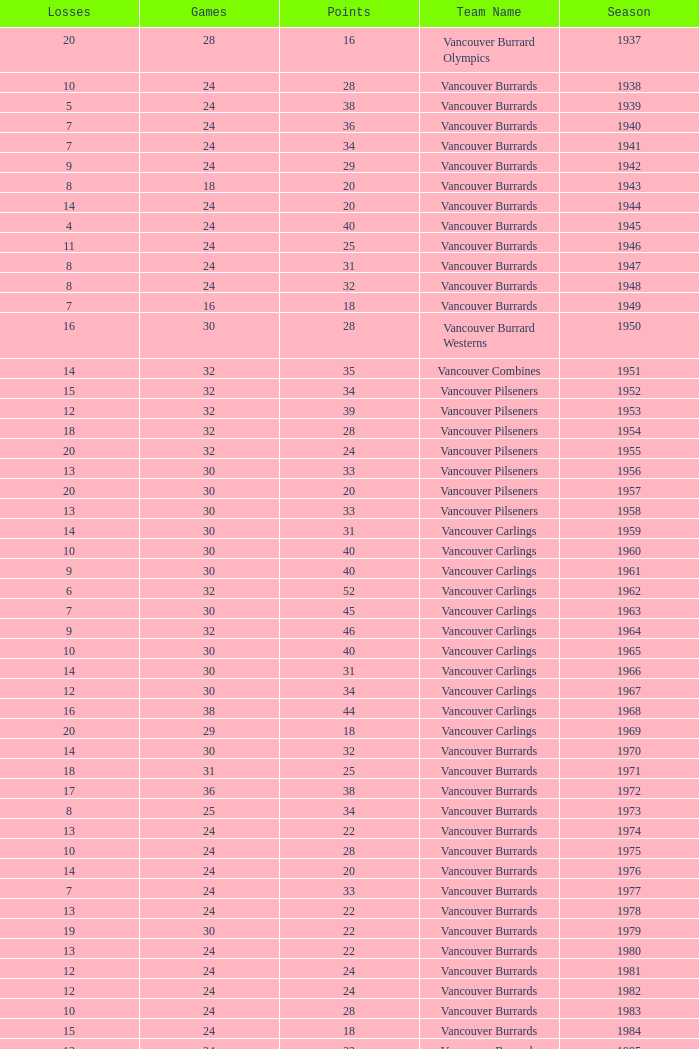What's the total number of points when the vancouver burrards have fewer than 9 losses and more than 24 games? 1.0. 